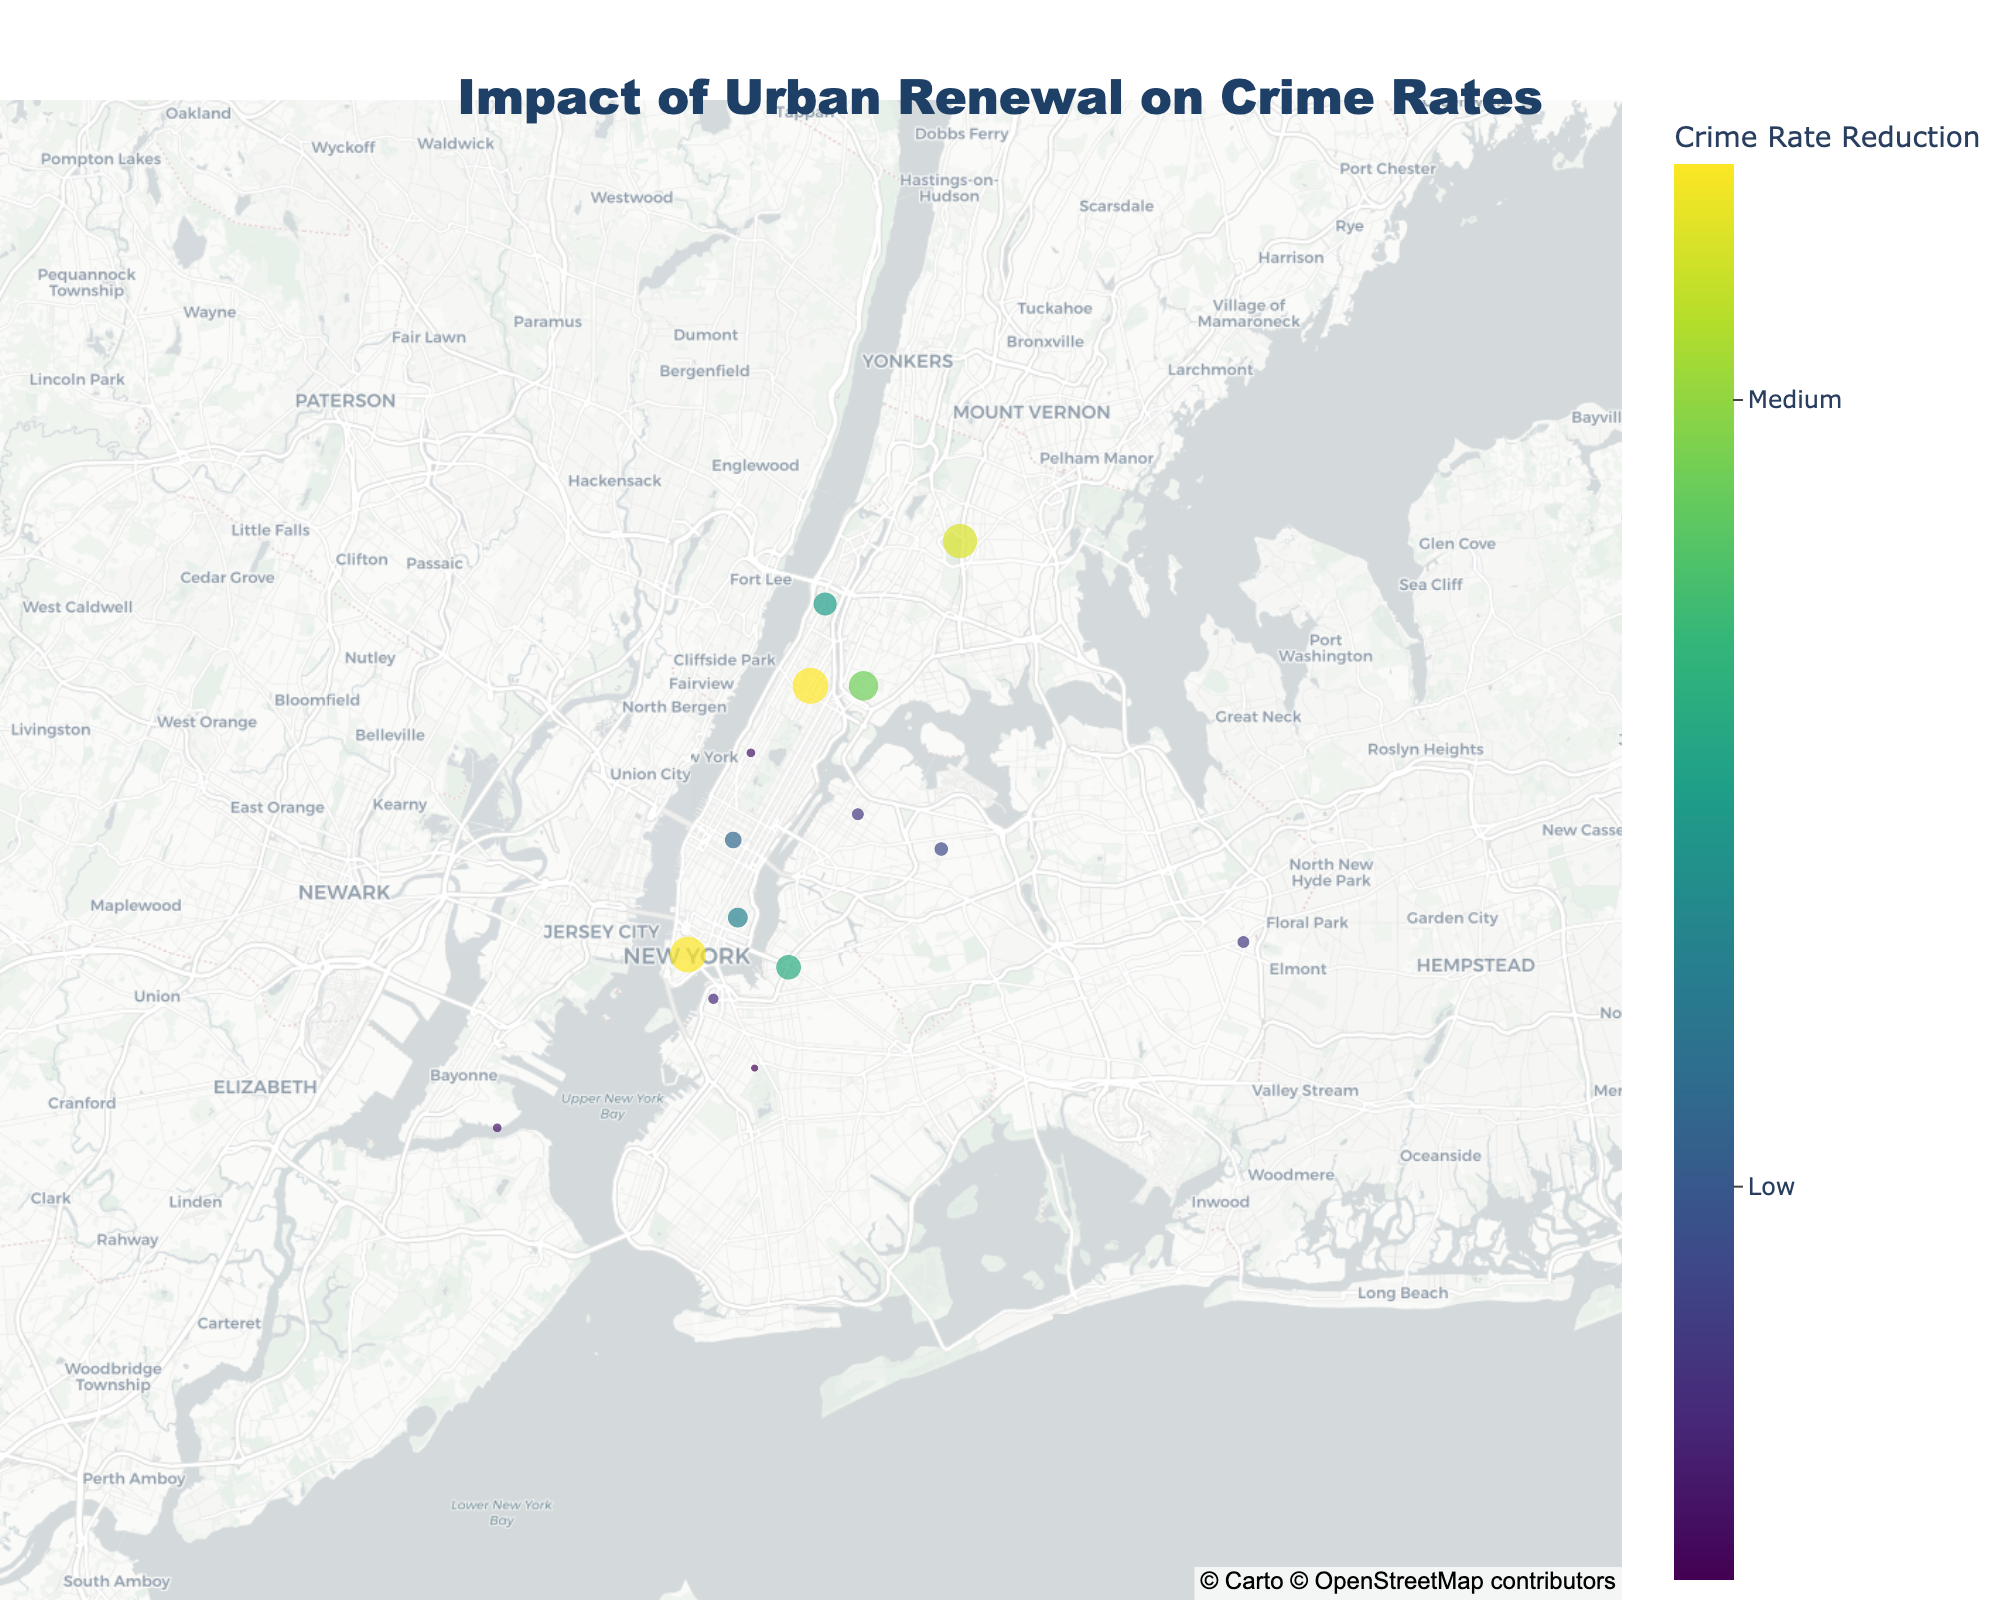What is the title of the geographic plot? The title is prominently displayed at the top of the figure. It reads "Impact of Urban Renewal on Crime Rates".
Answer: Impact of Urban Renewal on Crime Rates What information does the color scale represent? The color scale is labeled as "Crime Rate Reduction," where the different shades from the "Viridis" color scale indicate varying levels of crime rate reduction in the neighborhoods.
Answer: Crime Rate Reduction Which neighborhood had the highest reduction in crime rate? By looking at the size and color intensity of the markers, the South Bronx neighborhood stands out with the highest crime rate reduction.
Answer: South Bronx What is the crime rate in Harlem before and after urban renewal? The hover text provides specific details for each neighborhood. For Harlem, it shows "Before: 78" and "After: 55".
Answer: Before: 78, After: 55 Which area had the smallest reduction in crime rate? By examining the size and color intensity of the markers on the map, Upper West Side had the smallest reduction in crime rate because its marker has the least intense shade.
Answer: Upper West Side What is the average crime rate reduction across all neighborhoods? To calculate this: sum all the crime rate reductions (85-62 + 78-55 + 45-38 + 92-70 + 58-50 + 51-45 + 72-59 + 38-32 + 67-51 + 63-54 + 98-79 + 55-47 + 41-36 + 59-48 + 76-61), then divide by the number of neighborhoods (15). Total reduction: 358. Average reduction: 358/15.
Answer: 23.87 Which neighborhoods have a crime rate reduction greater than 20? Identify markers with significant size and color. Those neighborhoods are: Downtown, Harlem, Bronx Park, East Village, Williamsburg, South Bronx, Midtown, and Washington Heights.
Answer: Downtown, Harlem, Bronx Park, East Village, Williamsburg, South Bronx, Midtown, Washington Heights How does the crime rate reduction in Williamsburg compare to that of Queens Village? By checking the hover text, Williamsburg's reduction is 67-51 = 16, while Queens Village's reduction is 58-50 = 8. Williamsburg has a greater reduction than Queens Village.
Answer: Williamsburg > Queens Village What pattern can be observed in the spatial distribution of crime rate reductions? The map shows varying reductions across the neighborhoods, with more significant reductions often found in central and northern areas like Downtown, Harlem, and the South Bronx, suggesting that urban renewal might be particularly impactful in these regions.
Answer: Central and northern areas have higher reductions What is the center point of the map in terms of latitude and longitude? The center point can be derived from the map settings, indicating the mean latitude and longitude, which centers around (approx.) Latitude: 40.73, Longitude: -73.96.
Answer: Latitude: 40.73, Longitude: -73.96 